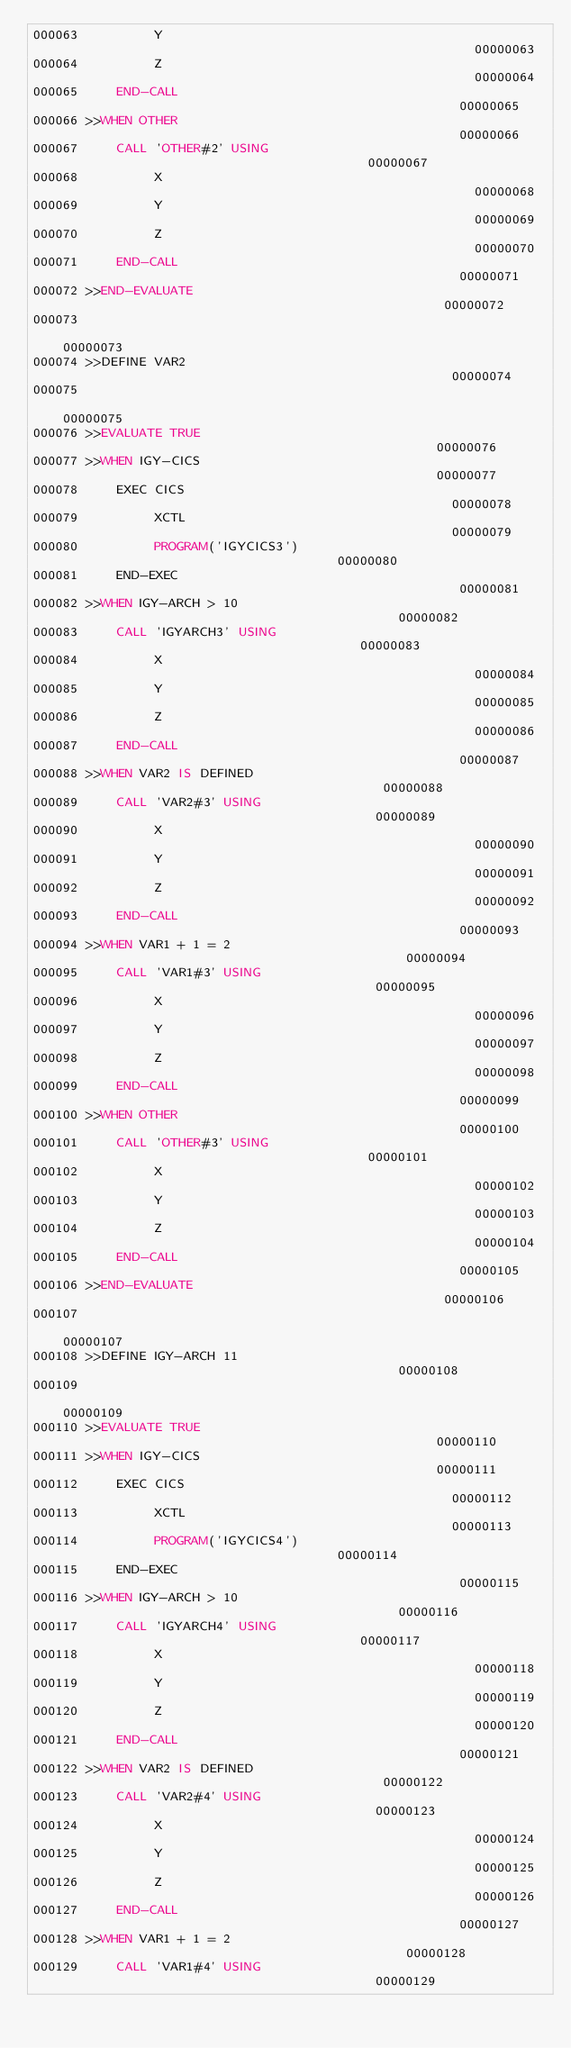Convert code to text. <code><loc_0><loc_0><loc_500><loc_500><_COBOL_>000063          Y                                                       00000063
000064          Z                                                       00000064
000065     END-CALL                                                     00000065
000066 >>WHEN OTHER                                                     00000066
000067     CALL 'OTHER#2' USING                                         00000067
000068          X                                                       00000068
000069          Y                                                       00000069
000070          Z                                                       00000070
000071     END-CALL                                                     00000071
000072 >>END-EVALUATE                                                   00000072
000073                                                                  00000073
000074 >>DEFINE VAR2                                                    00000074
000075                                                                  00000075
000076 >>EVALUATE TRUE                                                  00000076
000077 >>WHEN IGY-CICS                                                  00000077
000078     EXEC CICS                                                    00000078
000079          XCTL                                                    00000079
000080          PROGRAM('IGYCICS3')                                     00000080
000081     END-EXEC                                                     00000081
000082 >>WHEN IGY-ARCH > 10                                             00000082
000083     CALL 'IGYARCH3' USING                                        00000083
000084          X                                                       00000084
000085          Y                                                       00000085
000086          Z                                                       00000086
000087     END-CALL                                                     00000087
000088 >>WHEN VAR2 IS DEFINED                                           00000088
000089     CALL 'VAR2#3' USING                                          00000089
000090          X                                                       00000090
000091          Y                                                       00000091
000092          Z                                                       00000092
000093     END-CALL                                                     00000093
000094 >>WHEN VAR1 + 1 = 2                                              00000094
000095     CALL 'VAR1#3' USING                                          00000095
000096          X                                                       00000096
000097          Y                                                       00000097
000098          Z                                                       00000098
000099     END-CALL                                                     00000099
000100 >>WHEN OTHER                                                     00000100
000101     CALL 'OTHER#3' USING                                         00000101
000102          X                                                       00000102
000103          Y                                                       00000103
000104          Z                                                       00000104
000105     END-CALL                                                     00000105
000106 >>END-EVALUATE                                                   00000106
000107                                                                  00000107
000108 >>DEFINE IGY-ARCH 11                                             00000108
000109                                                                  00000109
000110 >>EVALUATE TRUE                                                  00000110
000111 >>WHEN IGY-CICS                                                  00000111
000112     EXEC CICS                                                    00000112
000113          XCTL                                                    00000113
000114          PROGRAM('IGYCICS4')                                     00000114
000115     END-EXEC                                                     00000115
000116 >>WHEN IGY-ARCH > 10                                             00000116
000117     CALL 'IGYARCH4' USING                                        00000117
000118          X                                                       00000118
000119          Y                                                       00000119
000120          Z                                                       00000120
000121     END-CALL                                                     00000121
000122 >>WHEN VAR2 IS DEFINED                                           00000122
000123     CALL 'VAR2#4' USING                                          00000123
000124          X                                                       00000124
000125          Y                                                       00000125
000126          Z                                                       00000126
000127     END-CALL                                                     00000127
000128 >>WHEN VAR1 + 1 = 2                                              00000128
000129     CALL 'VAR1#4' USING                                          00000129</code> 